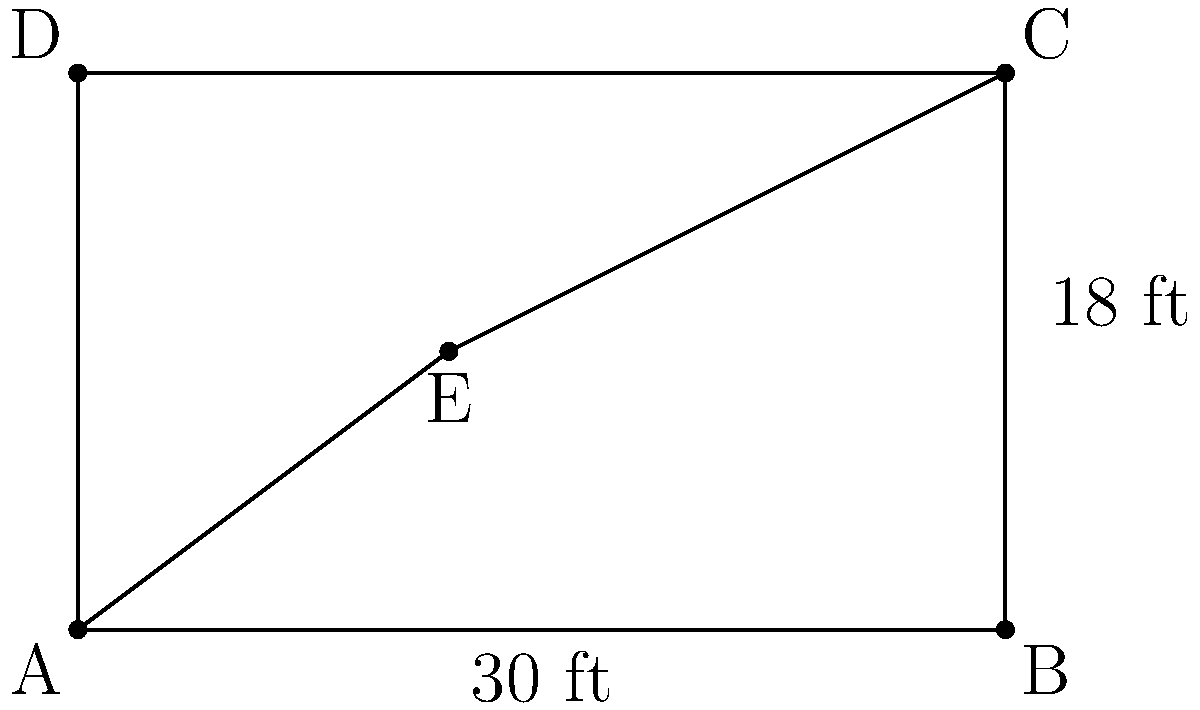The town of South Roxana is planning a new playground. The proposed layout is a rectangle with dimensions 30 ft by 18 ft. A diagonal path is planned from one corner to the opposite corner, passing through the center point of the rectangle. What is the angle formed by this diagonal path at the center point, rounded to the nearest degree? To solve this problem, let's follow these steps:

1) First, we need to understand that the diagonal path forms two right triangles within the rectangle.

2) We can focus on one of these right triangles. Let's consider the triangle formed by half the width, half the height, and half the diagonal.

3) The half-width of the rectangle is 30/2 = 15 ft.
   The half-height of the rectangle is 18/2 = 9 ft.

4) We can use the arctangent function to find the angle. The arctangent of the ratio of the opposite side to the adjacent side will give us half of the angle we're looking for.

5) $\tan(\theta/2) = 9/15 = 0.6$

6) Therefore, $\theta/2 = \arctan(0.6)$

7) $\theta = 2 * \arctan(0.6)$

8) Using a calculator or computer:
   $\theta = 2 * 30.9638... = 61.9276...$

9) Rounding to the nearest degree, we get 62°.
Answer: 62° 